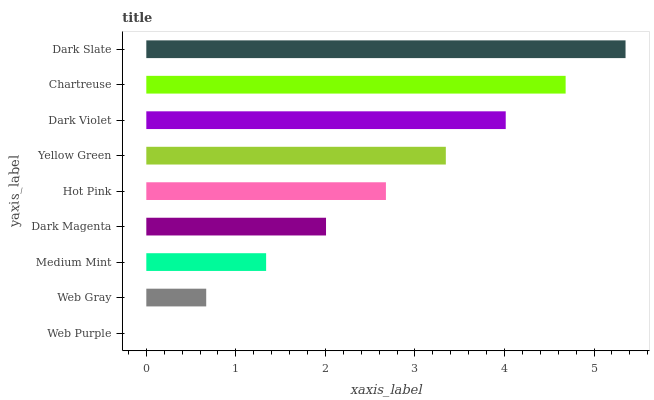Is Web Purple the minimum?
Answer yes or no. Yes. Is Dark Slate the maximum?
Answer yes or no. Yes. Is Web Gray the minimum?
Answer yes or no. No. Is Web Gray the maximum?
Answer yes or no. No. Is Web Gray greater than Web Purple?
Answer yes or no. Yes. Is Web Purple less than Web Gray?
Answer yes or no. Yes. Is Web Purple greater than Web Gray?
Answer yes or no. No. Is Web Gray less than Web Purple?
Answer yes or no. No. Is Hot Pink the high median?
Answer yes or no. Yes. Is Hot Pink the low median?
Answer yes or no. Yes. Is Yellow Green the high median?
Answer yes or no. No. Is Dark Violet the low median?
Answer yes or no. No. 